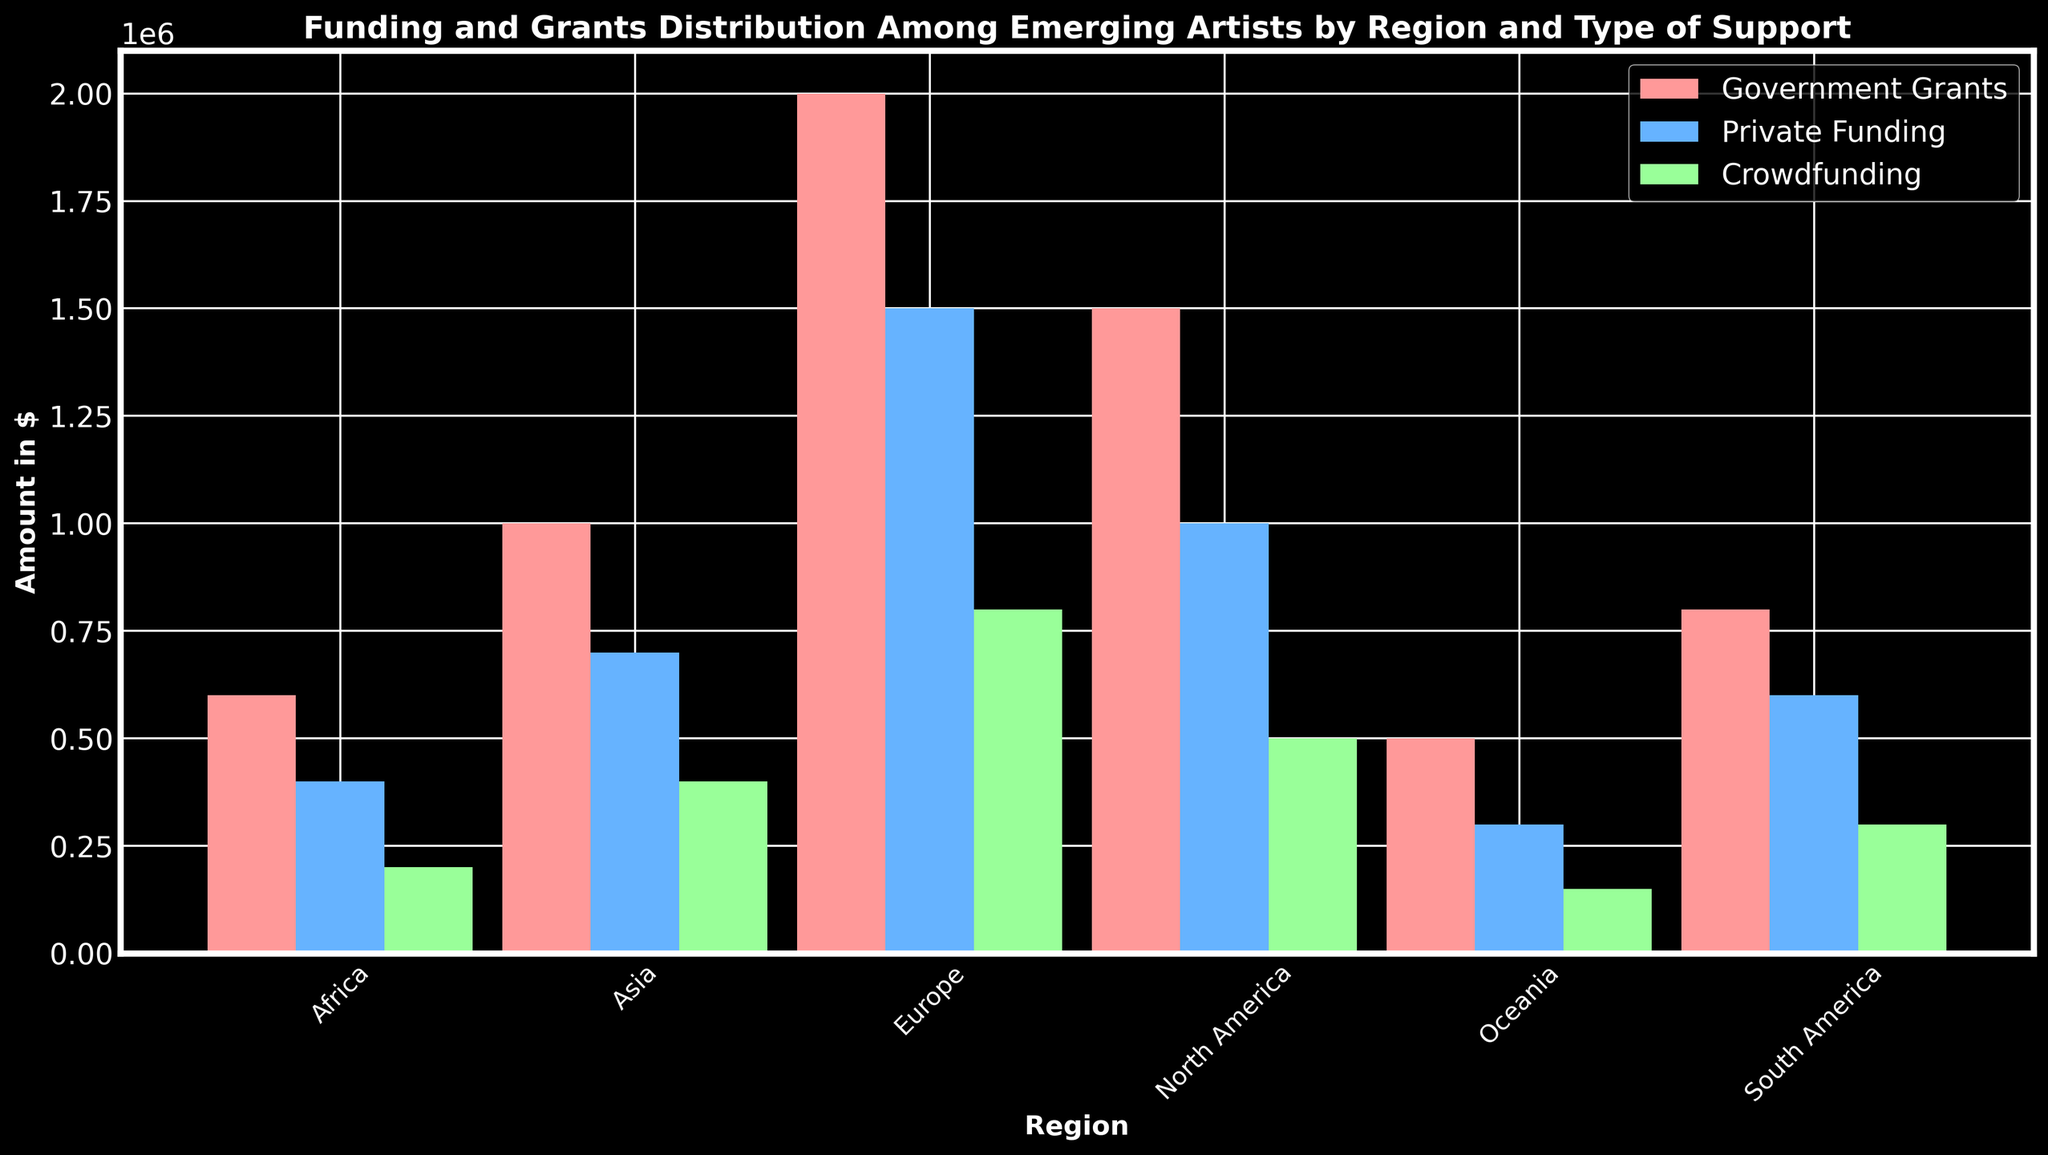How much total funding did North America receive? Sum the amounts of Government Grants, Private Funding, and Crowdfunding for North America. The grants are $1,500,000 + $1,000,000 + $500,000 = $3,000,000.
Answer: $3,000,000 Which region received the highest amount of Government Grants? Compare the Government Grants amounts for all regions: North America ($1,500,000), Europe ($2,000,000), Asia ($1,000,000), South America ($800,000), Africa ($600,000), Oceania ($500,000). Europe received the highest amount.
Answer: Europe How does the total funding for Asia compare to South America? Calculate the total funding for both Asia and South America. For Asia, it is $1,000,000 + $700,000 + $400,000 = $2,100,000. For South America, it is $800,000 + $600,000 + $300,000 = $1,700,000. Asia's total funding exceeds South America's by $400,000.
Answer: Asia has $400,000 more Which type of support is represented by the tallest green bar? Identify the type of support represented by the tallest green bar. According to the plot, the color code for Crowdfunding is green, so the region with the highest Crowdfunding bar is Europe (with $800,000).
Answer: Crowdfunding in Europe What is the sum of Private Funding across all regions? Add the Private Funding amounts for all regions: $1,000,000 (North America) + $1,500,000 (Europe) + $700,000 (Asia) + $600,000 (South America) + $400,000 (Africa) + $300,000 (Oceania) = $4,500,000.
Answer: $4,500,000 Compare the amount of Government Grants received by North America and Europe. Which region received less? Compare $1,500,000 (North America) and $2,000,000 (Europe). North America received less.
Answer: North America received less How much more Private Funding did Europe receive compared to Oceania? Subtract Oceania's Private Funding ($300,000) from Europe’s ($1,500,000): $1,500,000 – $300,000 = $1,200,000.
Answer: $1,200,000 Which region has the smallest total amount of funding? Calculate the total funding for each region and compare. For Oceania: $500,000 + $300,000 + $150,000 = $950,000. This is the smallest total amount.
Answer: Oceania What is the total Crowdfunding amount across all regions? Add the Crowdfunding amounts for all regions: $500,000 (North America) + $800,000 (Europe) + $400,000 (Asia) + $300,000 (South America) + $200,000 (Africa) + $150,000 (Oceania) = $2,350,000.
Answer: $2,350,000 